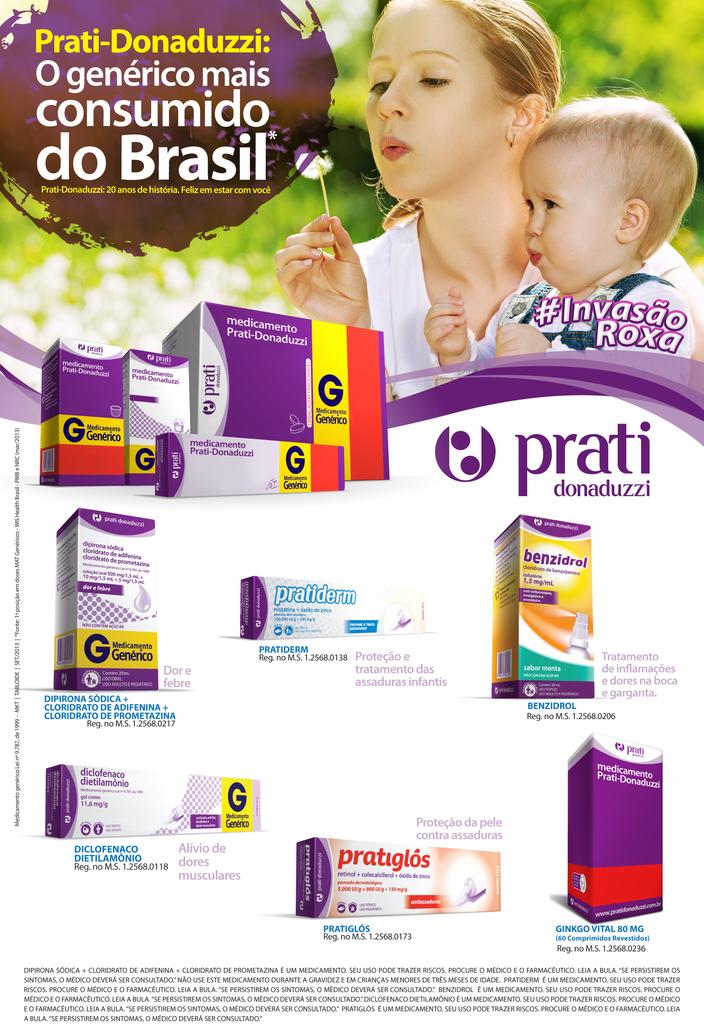What is the prand is showing on box on bottom?
Keep it short and to the point. Pratiglos. 